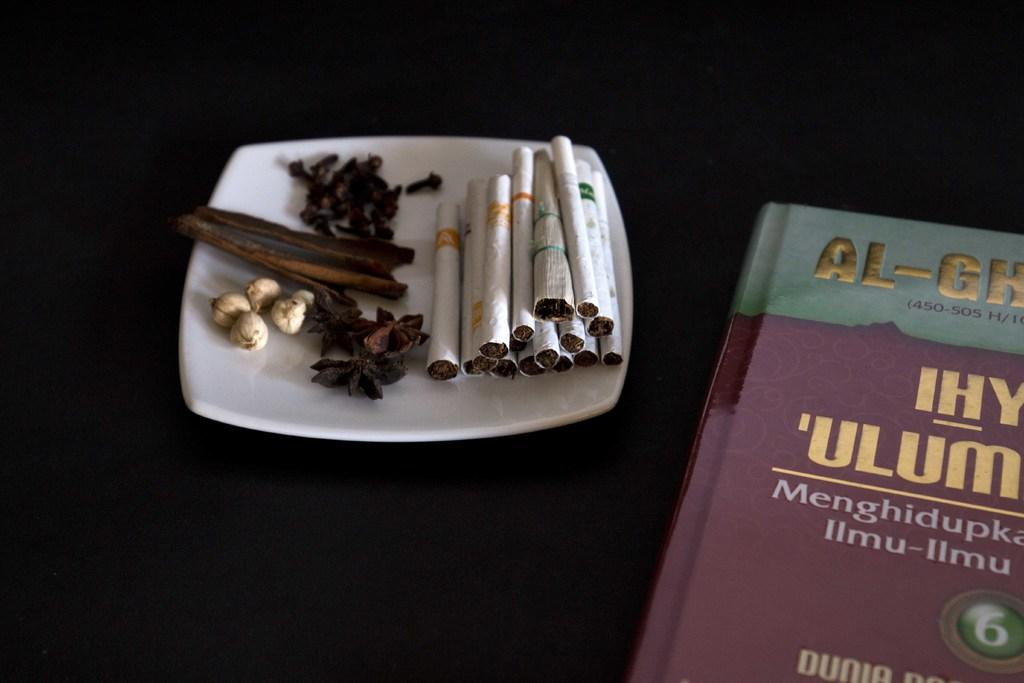<image>
Describe the image concisely. Some cigarettes on a plate next to a partially readable book that says AL-GH and IHY 'ULUM. 